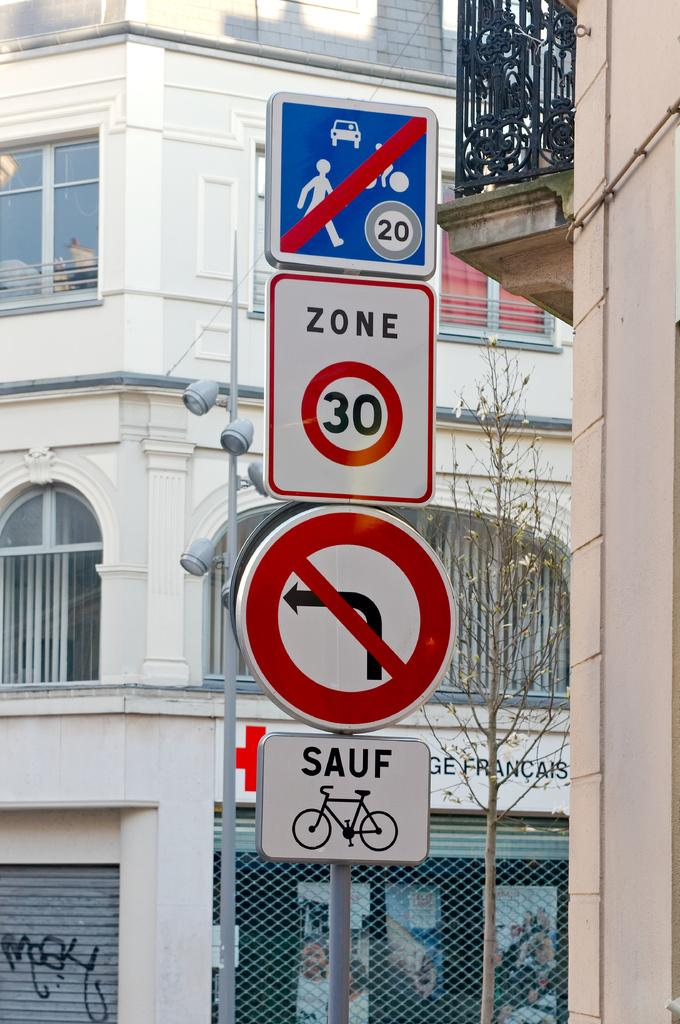<image>
Render a clear and concise summary of the photo. a number 30 on a sign among other signs 